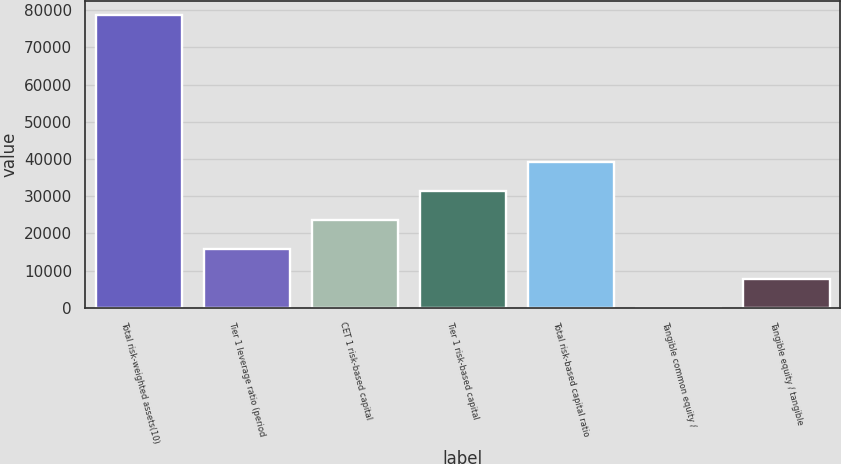<chart> <loc_0><loc_0><loc_500><loc_500><bar_chart><fcel>Total risk-weighted assets(10)<fcel>Tier 1 leverage ratio (period<fcel>CET 1 risk-based capital<fcel>Tier 1 risk-based capital<fcel>Total risk-based capital ratio<fcel>Tangible common equity /<fcel>Tangible equity / tangible<nl><fcel>78631<fcel>15732.1<fcel>23594.5<fcel>31456.9<fcel>39319.2<fcel>7.42<fcel>7869.78<nl></chart> 